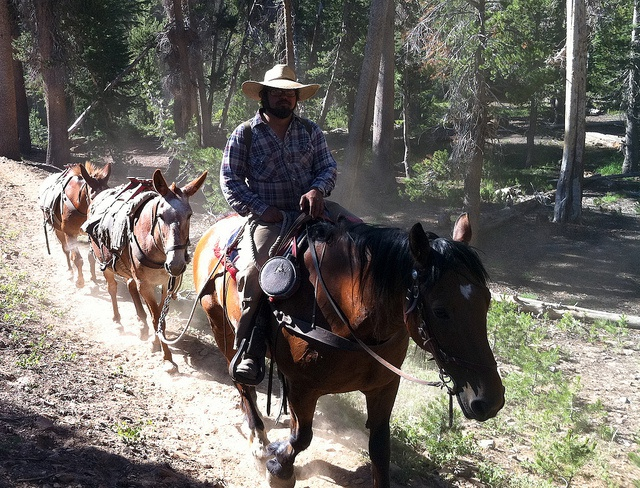Describe the objects in this image and their specific colors. I can see horse in black, white, gray, and maroon tones, people in black, gray, and white tones, horse in black, white, maroon, and gray tones, and horse in black, white, maroon, tan, and gray tones in this image. 